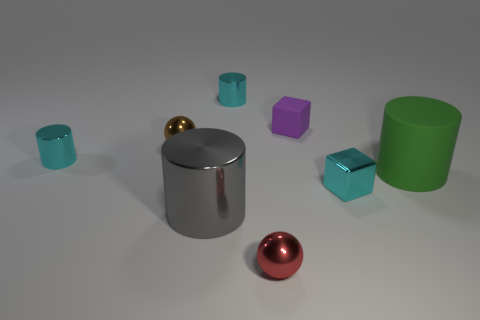Add 2 small red cylinders. How many objects exist? 10 Subtract all spheres. How many objects are left? 6 Subtract 0 yellow cylinders. How many objects are left? 8 Subtract all large cyan blocks. Subtract all tiny cyan objects. How many objects are left? 5 Add 1 spheres. How many spheres are left? 3 Add 2 brown metallic things. How many brown metallic things exist? 3 